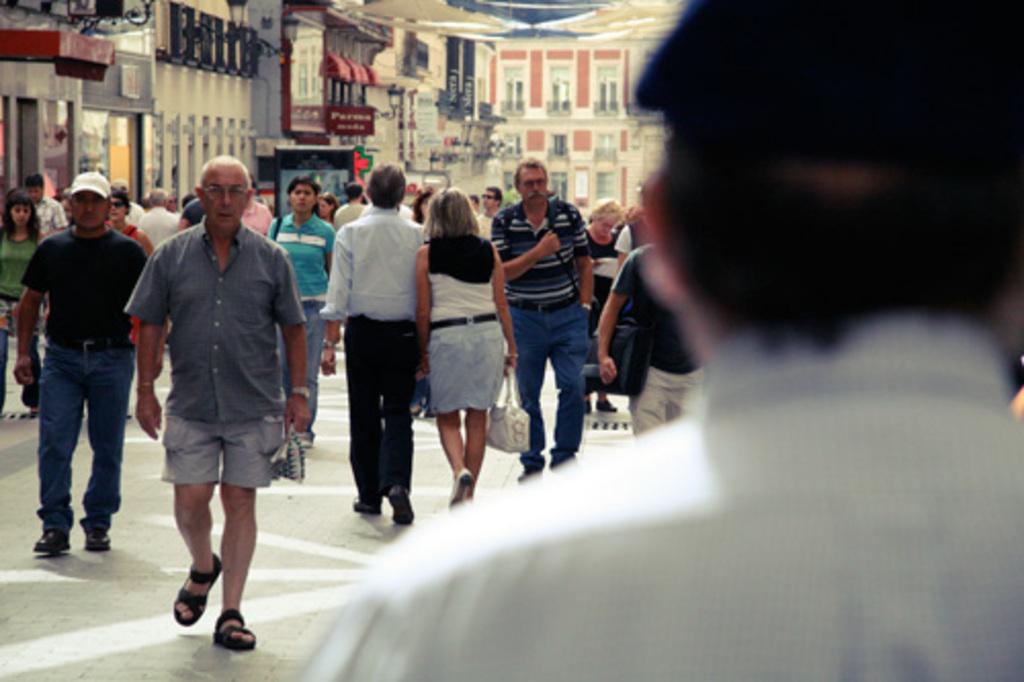Please provide a concise description of this image. In this image in front there is a person. In front of him there are a few people walking on the road. In the background of the image there are buildings, lights. 